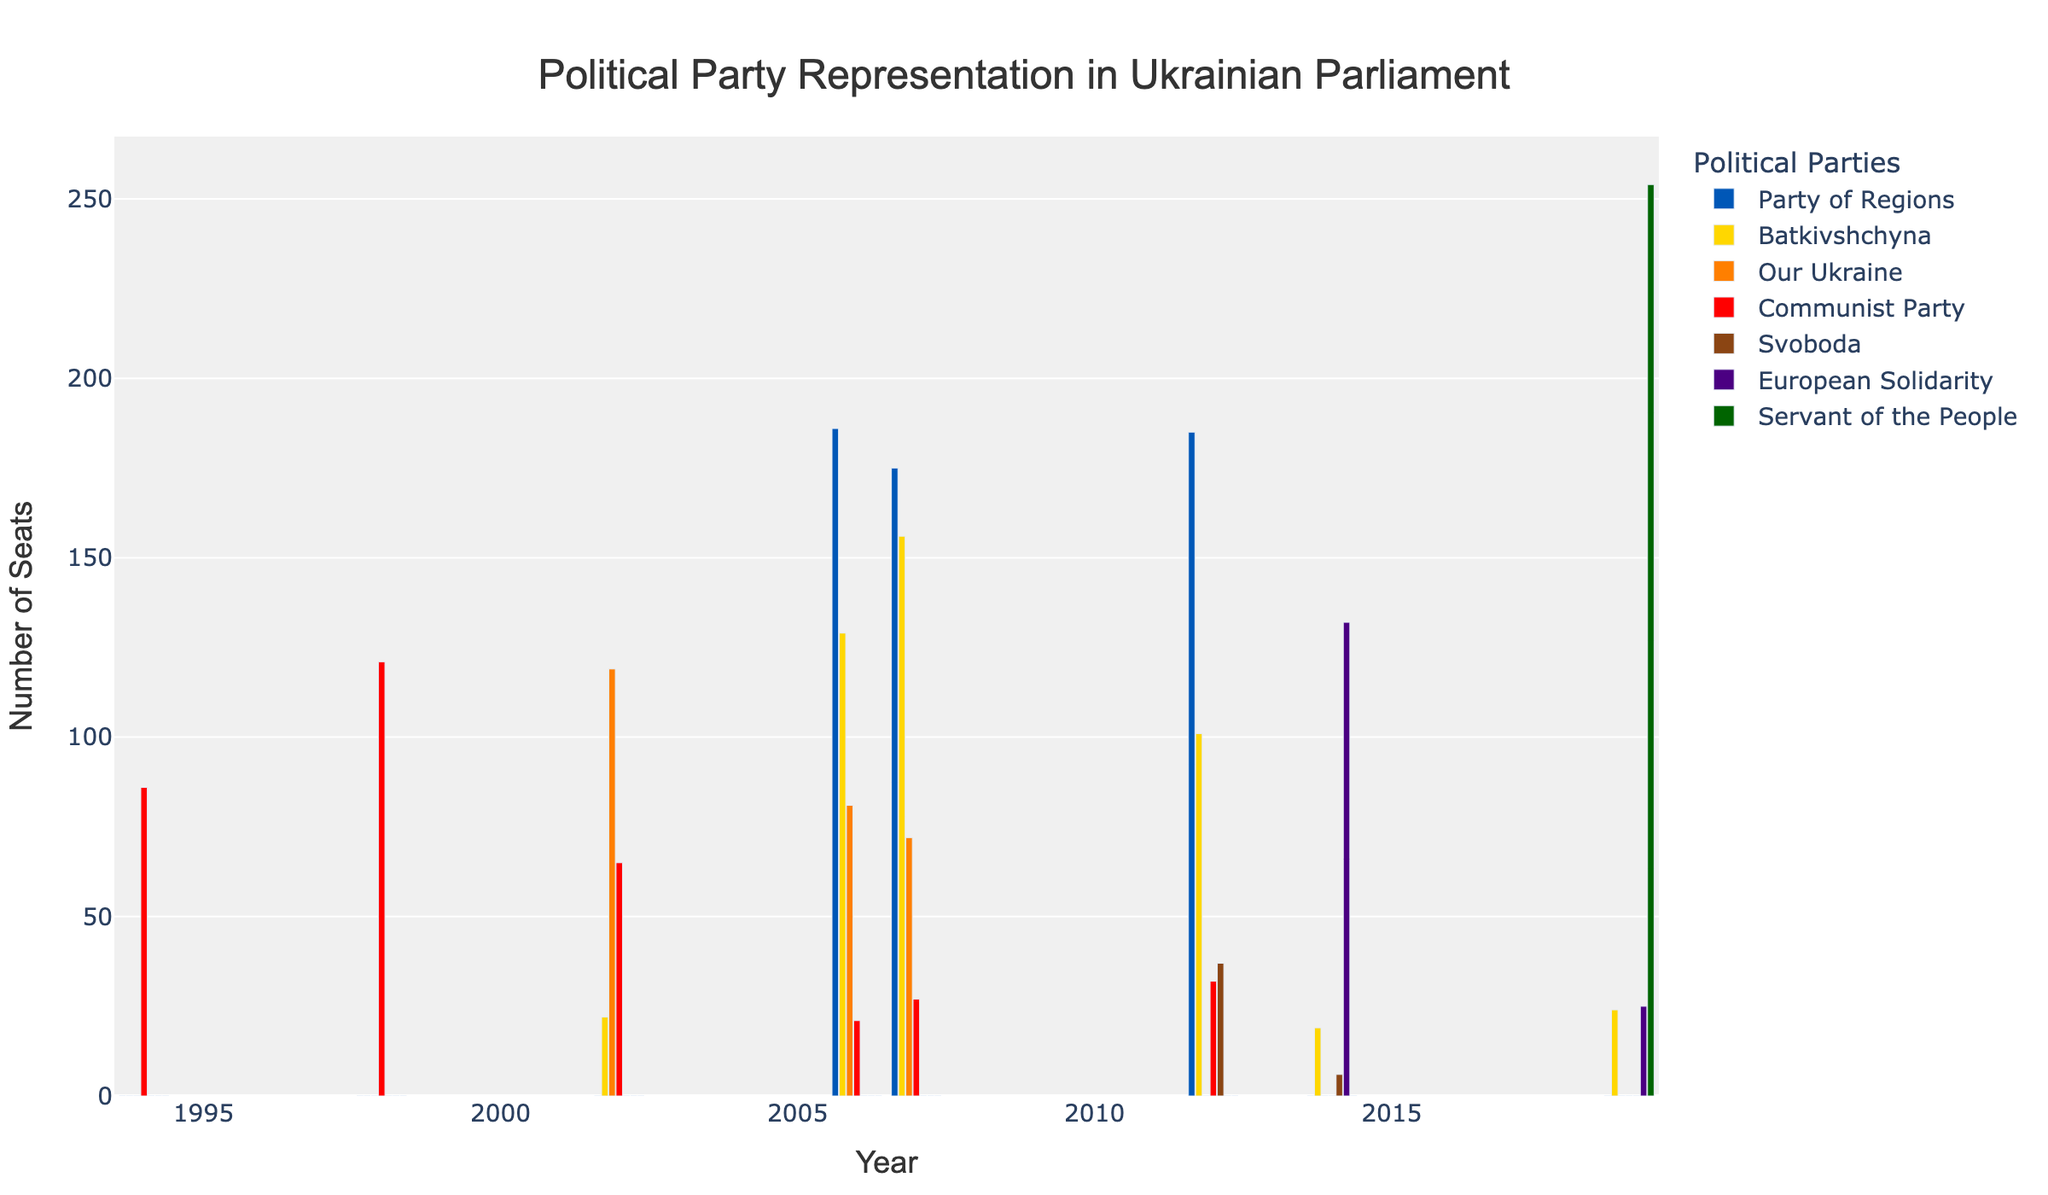who held the most seats in 2006? In the bar chart for the year 2006, the bar representing the Party of Regions is the tallest compared to the other bars. This denotes that the Party of Regions held the most seats in that year.
Answer: Party of Regions how many seats did communist party lose in 2014 compared to 1998? In 1998, the Communist Party held 121 seats. In 2014, they held 0 seats. The difference is calculated by subtracting the 2014 seats from the 1998 seats: 121 - 0 = 121.
Answer: 121 which year did svoboda first appear in parliament? In the bar chart, Svoboda first appears with 37 seats in 2012. There are no bars for Svoboda in earlier years.
Answer: 2012 which party had no representation in 2012 but gained seats in 2014? Looking at the bars for 2012 and 2014, the European Solidarity party had no representation in 2012 (0 seats) and then gained 132 seats in 2014.
Answer: European Solidarity how did the number of seats for european solidarity change from 2014 to 2019? In 2014, European Solidarity had 132 seats, dropping to 25 seats in 2019. The change is calculated by subtracting the 2019 seats from the 2014 seats: 132 - 25 = 107.
Answer: decreased by 107 what year did servant of the people first gain parliamentary seats? The first year where the bar for Servant of the People is present is 2019, where they obtained 254 seats.
Answer: 2019 how many seats did batkivshchyna gain between 2002 and 2007? In 2002, Batkivshchyna had 22 seats, increasing to 156 seats in 2007. The difference is calculated by subtracting the 2002 seats from the 2007 seats: 156 - 22 = 134.
Answer: 134 how much more representation did the party of regions have compared to communist party in 2006? In 2006, the Party of Regions had 186 seats while the Communist Party had 21 seats. The difference is calculated by subtracting the Communist Party's seats from the Party of Regions's seats: 186 - 21 = 165.
Answer: 165 